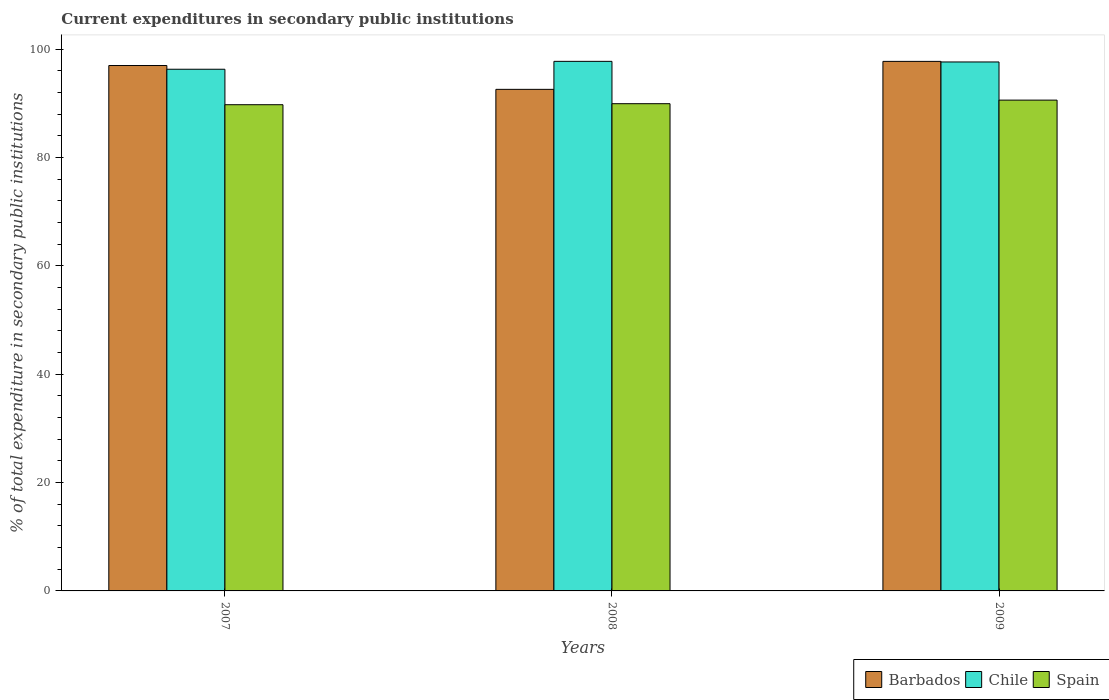How many different coloured bars are there?
Keep it short and to the point. 3. Are the number of bars on each tick of the X-axis equal?
Your answer should be very brief. Yes. What is the current expenditures in secondary public institutions in Spain in 2009?
Ensure brevity in your answer.  90.61. Across all years, what is the maximum current expenditures in secondary public institutions in Barbados?
Offer a terse response. 97.76. Across all years, what is the minimum current expenditures in secondary public institutions in Barbados?
Your response must be concise. 92.59. What is the total current expenditures in secondary public institutions in Barbados in the graph?
Provide a short and direct response. 287.35. What is the difference between the current expenditures in secondary public institutions in Barbados in 2007 and that in 2008?
Your answer should be compact. 4.4. What is the difference between the current expenditures in secondary public institutions in Chile in 2007 and the current expenditures in secondary public institutions in Barbados in 2009?
Your answer should be compact. -1.45. What is the average current expenditures in secondary public institutions in Spain per year?
Offer a terse response. 90.1. In the year 2007, what is the difference between the current expenditures in secondary public institutions in Spain and current expenditures in secondary public institutions in Chile?
Make the answer very short. -6.55. In how many years, is the current expenditures in secondary public institutions in Chile greater than 56 %?
Provide a short and direct response. 3. What is the ratio of the current expenditures in secondary public institutions in Spain in 2008 to that in 2009?
Ensure brevity in your answer.  0.99. Is the current expenditures in secondary public institutions in Spain in 2008 less than that in 2009?
Make the answer very short. Yes. Is the difference between the current expenditures in secondary public institutions in Spain in 2007 and 2009 greater than the difference between the current expenditures in secondary public institutions in Chile in 2007 and 2009?
Offer a very short reply. Yes. What is the difference between the highest and the second highest current expenditures in secondary public institutions in Barbados?
Your response must be concise. 0.76. What is the difference between the highest and the lowest current expenditures in secondary public institutions in Barbados?
Make the answer very short. 5.16. In how many years, is the current expenditures in secondary public institutions in Barbados greater than the average current expenditures in secondary public institutions in Barbados taken over all years?
Offer a terse response. 2. What does the 1st bar from the left in 2008 represents?
Make the answer very short. Barbados. What does the 3rd bar from the right in 2007 represents?
Offer a terse response. Barbados. Are all the bars in the graph horizontal?
Your response must be concise. No. How many years are there in the graph?
Ensure brevity in your answer.  3. What is the difference between two consecutive major ticks on the Y-axis?
Offer a very short reply. 20. Are the values on the major ticks of Y-axis written in scientific E-notation?
Make the answer very short. No. Does the graph contain grids?
Offer a terse response. No. Where does the legend appear in the graph?
Make the answer very short. Bottom right. How many legend labels are there?
Your answer should be very brief. 3. What is the title of the graph?
Offer a terse response. Current expenditures in secondary public institutions. What is the label or title of the Y-axis?
Provide a succinct answer. % of total expenditure in secondary public institutions. What is the % of total expenditure in secondary public institutions in Barbados in 2007?
Offer a very short reply. 96.99. What is the % of total expenditure in secondary public institutions in Chile in 2007?
Provide a succinct answer. 96.31. What is the % of total expenditure in secondary public institutions in Spain in 2007?
Your response must be concise. 89.76. What is the % of total expenditure in secondary public institutions of Barbados in 2008?
Ensure brevity in your answer.  92.59. What is the % of total expenditure in secondary public institutions of Chile in 2008?
Provide a succinct answer. 97.76. What is the % of total expenditure in secondary public institutions of Spain in 2008?
Make the answer very short. 89.95. What is the % of total expenditure in secondary public institutions in Barbados in 2009?
Your answer should be very brief. 97.76. What is the % of total expenditure in secondary public institutions of Chile in 2009?
Offer a terse response. 97.65. What is the % of total expenditure in secondary public institutions in Spain in 2009?
Your response must be concise. 90.61. Across all years, what is the maximum % of total expenditure in secondary public institutions in Barbados?
Your answer should be compact. 97.76. Across all years, what is the maximum % of total expenditure in secondary public institutions of Chile?
Your answer should be compact. 97.76. Across all years, what is the maximum % of total expenditure in secondary public institutions of Spain?
Keep it short and to the point. 90.61. Across all years, what is the minimum % of total expenditure in secondary public institutions in Barbados?
Provide a short and direct response. 92.59. Across all years, what is the minimum % of total expenditure in secondary public institutions of Chile?
Your answer should be compact. 96.31. Across all years, what is the minimum % of total expenditure in secondary public institutions of Spain?
Provide a succinct answer. 89.76. What is the total % of total expenditure in secondary public institutions of Barbados in the graph?
Your response must be concise. 287.35. What is the total % of total expenditure in secondary public institutions in Chile in the graph?
Offer a terse response. 291.72. What is the total % of total expenditure in secondary public institutions of Spain in the graph?
Your answer should be compact. 270.31. What is the difference between the % of total expenditure in secondary public institutions in Barbados in 2007 and that in 2008?
Offer a very short reply. 4.4. What is the difference between the % of total expenditure in secondary public institutions in Chile in 2007 and that in 2008?
Provide a succinct answer. -1.46. What is the difference between the % of total expenditure in secondary public institutions in Spain in 2007 and that in 2008?
Your answer should be compact. -0.19. What is the difference between the % of total expenditure in secondary public institutions of Barbados in 2007 and that in 2009?
Your answer should be very brief. -0.76. What is the difference between the % of total expenditure in secondary public institutions in Chile in 2007 and that in 2009?
Keep it short and to the point. -1.35. What is the difference between the % of total expenditure in secondary public institutions in Spain in 2007 and that in 2009?
Make the answer very short. -0.85. What is the difference between the % of total expenditure in secondary public institutions of Barbados in 2008 and that in 2009?
Offer a very short reply. -5.16. What is the difference between the % of total expenditure in secondary public institutions in Chile in 2008 and that in 2009?
Your response must be concise. 0.11. What is the difference between the % of total expenditure in secondary public institutions of Spain in 2008 and that in 2009?
Give a very brief answer. -0.66. What is the difference between the % of total expenditure in secondary public institutions in Barbados in 2007 and the % of total expenditure in secondary public institutions in Chile in 2008?
Offer a very short reply. -0.77. What is the difference between the % of total expenditure in secondary public institutions in Barbados in 2007 and the % of total expenditure in secondary public institutions in Spain in 2008?
Make the answer very short. 7.05. What is the difference between the % of total expenditure in secondary public institutions of Chile in 2007 and the % of total expenditure in secondary public institutions of Spain in 2008?
Provide a short and direct response. 6.36. What is the difference between the % of total expenditure in secondary public institutions of Barbados in 2007 and the % of total expenditure in secondary public institutions of Chile in 2009?
Your answer should be very brief. -0.66. What is the difference between the % of total expenditure in secondary public institutions in Barbados in 2007 and the % of total expenditure in secondary public institutions in Spain in 2009?
Your response must be concise. 6.39. What is the difference between the % of total expenditure in secondary public institutions of Chile in 2007 and the % of total expenditure in secondary public institutions of Spain in 2009?
Your answer should be compact. 5.7. What is the difference between the % of total expenditure in secondary public institutions of Barbados in 2008 and the % of total expenditure in secondary public institutions of Chile in 2009?
Offer a terse response. -5.06. What is the difference between the % of total expenditure in secondary public institutions of Barbados in 2008 and the % of total expenditure in secondary public institutions of Spain in 2009?
Offer a very short reply. 1.99. What is the difference between the % of total expenditure in secondary public institutions of Chile in 2008 and the % of total expenditure in secondary public institutions of Spain in 2009?
Your response must be concise. 7.16. What is the average % of total expenditure in secondary public institutions in Barbados per year?
Provide a short and direct response. 95.78. What is the average % of total expenditure in secondary public institutions in Chile per year?
Ensure brevity in your answer.  97.24. What is the average % of total expenditure in secondary public institutions in Spain per year?
Your response must be concise. 90.11. In the year 2007, what is the difference between the % of total expenditure in secondary public institutions of Barbados and % of total expenditure in secondary public institutions of Chile?
Provide a short and direct response. 0.69. In the year 2007, what is the difference between the % of total expenditure in secondary public institutions in Barbados and % of total expenditure in secondary public institutions in Spain?
Offer a very short reply. 7.23. In the year 2007, what is the difference between the % of total expenditure in secondary public institutions of Chile and % of total expenditure in secondary public institutions of Spain?
Your answer should be very brief. 6.55. In the year 2008, what is the difference between the % of total expenditure in secondary public institutions in Barbados and % of total expenditure in secondary public institutions in Chile?
Your answer should be very brief. -5.17. In the year 2008, what is the difference between the % of total expenditure in secondary public institutions in Barbados and % of total expenditure in secondary public institutions in Spain?
Provide a succinct answer. 2.65. In the year 2008, what is the difference between the % of total expenditure in secondary public institutions of Chile and % of total expenditure in secondary public institutions of Spain?
Your answer should be very brief. 7.82. In the year 2009, what is the difference between the % of total expenditure in secondary public institutions of Barbados and % of total expenditure in secondary public institutions of Chile?
Make the answer very short. 0.11. In the year 2009, what is the difference between the % of total expenditure in secondary public institutions in Barbados and % of total expenditure in secondary public institutions in Spain?
Ensure brevity in your answer.  7.15. In the year 2009, what is the difference between the % of total expenditure in secondary public institutions of Chile and % of total expenditure in secondary public institutions of Spain?
Make the answer very short. 7.04. What is the ratio of the % of total expenditure in secondary public institutions in Barbados in 2007 to that in 2008?
Provide a short and direct response. 1.05. What is the ratio of the % of total expenditure in secondary public institutions in Chile in 2007 to that in 2008?
Offer a terse response. 0.99. What is the ratio of the % of total expenditure in secondary public institutions of Chile in 2007 to that in 2009?
Your answer should be compact. 0.99. What is the ratio of the % of total expenditure in secondary public institutions in Spain in 2007 to that in 2009?
Your answer should be very brief. 0.99. What is the ratio of the % of total expenditure in secondary public institutions of Barbados in 2008 to that in 2009?
Make the answer very short. 0.95. What is the ratio of the % of total expenditure in secondary public institutions of Chile in 2008 to that in 2009?
Provide a short and direct response. 1. What is the ratio of the % of total expenditure in secondary public institutions in Spain in 2008 to that in 2009?
Ensure brevity in your answer.  0.99. What is the difference between the highest and the second highest % of total expenditure in secondary public institutions in Barbados?
Make the answer very short. 0.76. What is the difference between the highest and the second highest % of total expenditure in secondary public institutions in Chile?
Offer a very short reply. 0.11. What is the difference between the highest and the second highest % of total expenditure in secondary public institutions in Spain?
Provide a short and direct response. 0.66. What is the difference between the highest and the lowest % of total expenditure in secondary public institutions in Barbados?
Offer a terse response. 5.16. What is the difference between the highest and the lowest % of total expenditure in secondary public institutions of Chile?
Your answer should be compact. 1.46. What is the difference between the highest and the lowest % of total expenditure in secondary public institutions of Spain?
Make the answer very short. 0.85. 